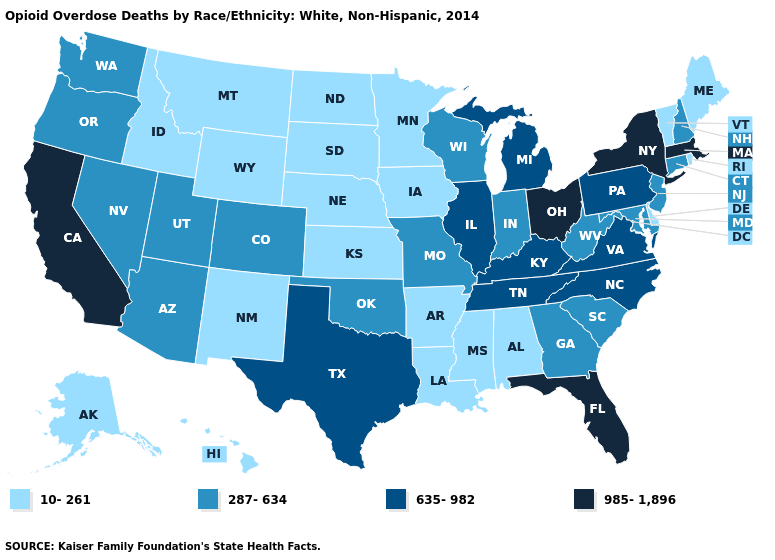Does California have the highest value in the USA?
Keep it brief. Yes. Does Colorado have the highest value in the West?
Keep it brief. No. Name the states that have a value in the range 985-1,896?
Keep it brief. California, Florida, Massachusetts, New York, Ohio. Among the states that border Texas , does Oklahoma have the lowest value?
Give a very brief answer. No. How many symbols are there in the legend?
Be succinct. 4. Is the legend a continuous bar?
Short answer required. No. What is the lowest value in states that border North Dakota?
Write a very short answer. 10-261. Name the states that have a value in the range 287-634?
Be succinct. Arizona, Colorado, Connecticut, Georgia, Indiana, Maryland, Missouri, Nevada, New Hampshire, New Jersey, Oklahoma, Oregon, South Carolina, Utah, Washington, West Virginia, Wisconsin. Name the states that have a value in the range 287-634?
Short answer required. Arizona, Colorado, Connecticut, Georgia, Indiana, Maryland, Missouri, Nevada, New Hampshire, New Jersey, Oklahoma, Oregon, South Carolina, Utah, Washington, West Virginia, Wisconsin. Which states have the lowest value in the USA?
Concise answer only. Alabama, Alaska, Arkansas, Delaware, Hawaii, Idaho, Iowa, Kansas, Louisiana, Maine, Minnesota, Mississippi, Montana, Nebraska, New Mexico, North Dakota, Rhode Island, South Dakota, Vermont, Wyoming. Among the states that border Wisconsin , does Minnesota have the highest value?
Keep it brief. No. What is the value of Georgia?
Keep it brief. 287-634. Name the states that have a value in the range 635-982?
Give a very brief answer. Illinois, Kentucky, Michigan, North Carolina, Pennsylvania, Tennessee, Texas, Virginia. What is the lowest value in the USA?
Answer briefly. 10-261. 